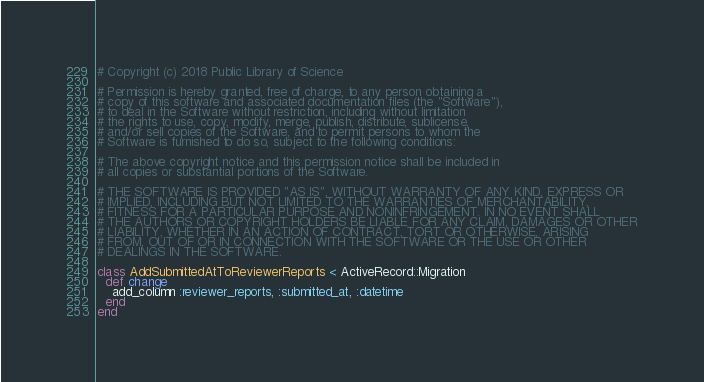Convert code to text. <code><loc_0><loc_0><loc_500><loc_500><_Ruby_># Copyright (c) 2018 Public Library of Science

# Permission is hereby granted, free of charge, to any person obtaining a
# copy of this software and associated documentation files (the "Software"),
# to deal in the Software without restriction, including without limitation
# the rights to use, copy, modify, merge, publish, distribute, sublicense,
# and/or sell copies of the Software, and to permit persons to whom the
# Software is furnished to do so, subject to the following conditions:

# The above copyright notice and this permission notice shall be included in
# all copies or substantial portions of the Software.

# THE SOFTWARE IS PROVIDED "AS IS", WITHOUT WARRANTY OF ANY KIND, EXPRESS OR
# IMPLIED, INCLUDING BUT NOT LIMITED TO THE WARRANTIES OF MERCHANTABILITY,
# FITNESS FOR A PARTICULAR PURPOSE AND NONINFRINGEMENT. IN NO EVENT SHALL
# THE AUTHORS OR COPYRIGHT HOLDERS BE LIABLE FOR ANY CLAIM, DAMAGES OR OTHER
# LIABILITY, WHETHER IN AN ACTION OF CONTRACT, TORT OR OTHERWISE, ARISING
# FROM, OUT OF OR IN CONNECTION WITH THE SOFTWARE OR THE USE OR OTHER
# DEALINGS IN THE SOFTWARE.

class AddSubmittedAtToReviewerReports < ActiveRecord::Migration
  def change
    add_column :reviewer_reports, :submitted_at, :datetime
  end
end
</code> 